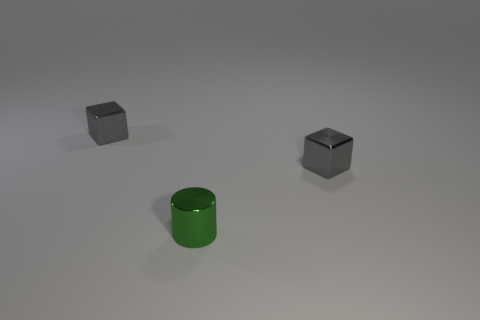Do the metal cylinder and the gray cube that is to the left of the green thing have the same size?
Your response must be concise. Yes. What number of tiny gray metal things are on the right side of the small gray metal object to the left of the green shiny thing?
Your response must be concise. 1. What is the color of the block that is in front of the gray block that is left of the small shiny cylinder?
Offer a very short reply. Gray. Is the number of green shiny cylinders greater than the number of gray blocks?
Offer a terse response. No. How many metal cubes are the same size as the shiny cylinder?
Offer a very short reply. 2. Are the small green cylinder and the thing that is left of the green cylinder made of the same material?
Offer a very short reply. Yes. Are there fewer gray objects than blue shiny objects?
Ensure brevity in your answer.  No. How many small green objects are left of the small gray cube that is in front of the tiny thing that is on the left side of the green metallic cylinder?
Keep it short and to the point. 1. Are there fewer shiny objects to the left of the tiny green metallic thing than green objects?
Provide a short and direct response. No. What number of big objects are either gray things or green cylinders?
Your response must be concise. 0. 